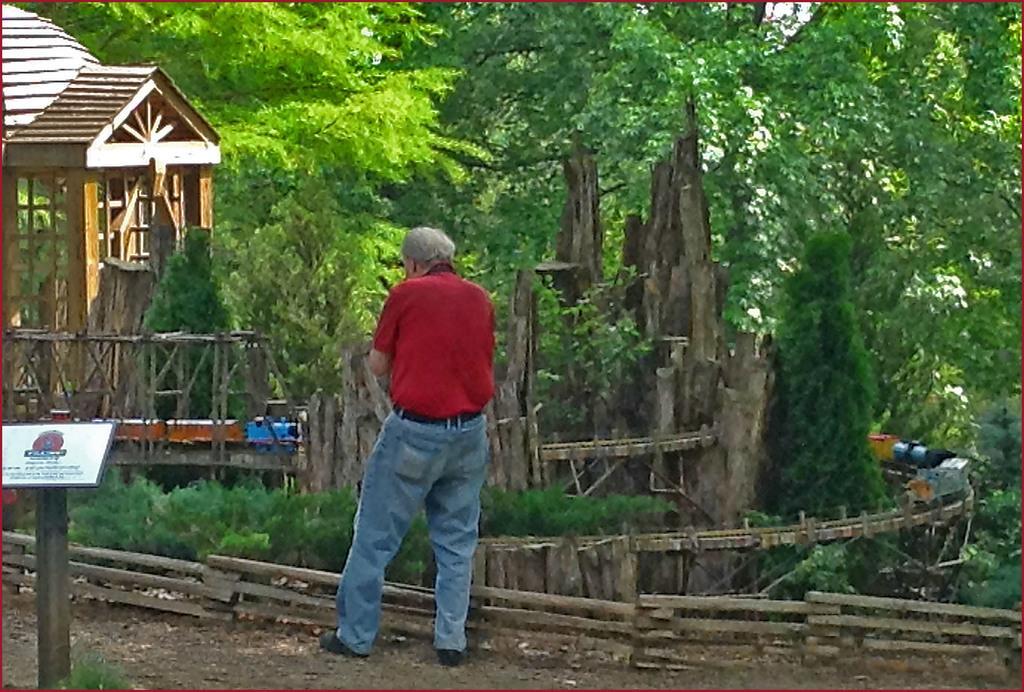Could you give a brief overview of what you see in this image? There is a person standing. Near to him there is a small wooden fencing. On the left side there is a pole with board. In the back there is a wooden building and trees. 